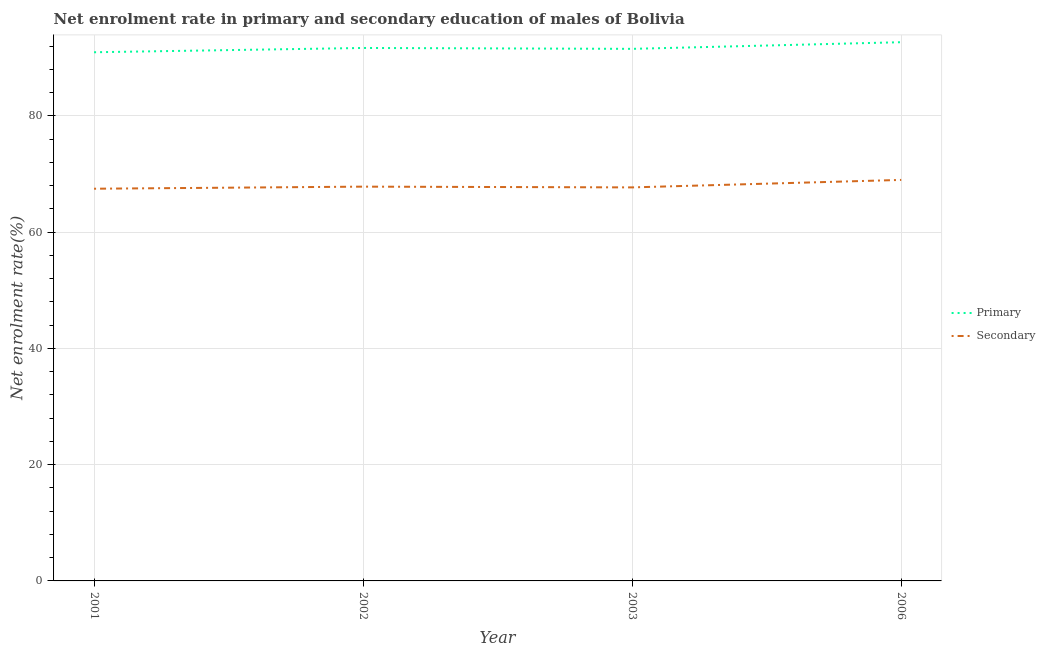Does the line corresponding to enrollment rate in secondary education intersect with the line corresponding to enrollment rate in primary education?
Give a very brief answer. No. What is the enrollment rate in secondary education in 2003?
Your answer should be very brief. 67.69. Across all years, what is the maximum enrollment rate in primary education?
Offer a very short reply. 92.66. Across all years, what is the minimum enrollment rate in secondary education?
Provide a short and direct response. 67.46. What is the total enrollment rate in primary education in the graph?
Give a very brief answer. 366.77. What is the difference between the enrollment rate in secondary education in 2001 and that in 2003?
Your answer should be very brief. -0.23. What is the difference between the enrollment rate in primary education in 2003 and the enrollment rate in secondary education in 2001?
Your response must be concise. 24.06. What is the average enrollment rate in primary education per year?
Offer a terse response. 91.69. In the year 2003, what is the difference between the enrollment rate in primary education and enrollment rate in secondary education?
Provide a succinct answer. 23.83. In how many years, is the enrollment rate in secondary education greater than 40 %?
Your response must be concise. 4. What is the ratio of the enrollment rate in primary education in 2002 to that in 2006?
Make the answer very short. 0.99. Is the difference between the enrollment rate in secondary education in 2002 and 2003 greater than the difference between the enrollment rate in primary education in 2002 and 2003?
Make the answer very short. No. What is the difference between the highest and the second highest enrollment rate in secondary education?
Provide a succinct answer. 1.16. What is the difference between the highest and the lowest enrollment rate in secondary education?
Your answer should be very brief. 1.51. In how many years, is the enrollment rate in primary education greater than the average enrollment rate in primary education taken over all years?
Provide a short and direct response. 1. Does the enrollment rate in primary education monotonically increase over the years?
Offer a very short reply. No. Is the enrollment rate in primary education strictly less than the enrollment rate in secondary education over the years?
Your answer should be very brief. No. What is the difference between two consecutive major ticks on the Y-axis?
Offer a very short reply. 20. Are the values on the major ticks of Y-axis written in scientific E-notation?
Your answer should be very brief. No. Does the graph contain grids?
Your response must be concise. Yes. Where does the legend appear in the graph?
Your response must be concise. Center right. How are the legend labels stacked?
Offer a terse response. Vertical. What is the title of the graph?
Offer a terse response. Net enrolment rate in primary and secondary education of males of Bolivia. Does "Pregnant women" appear as one of the legend labels in the graph?
Give a very brief answer. No. What is the label or title of the Y-axis?
Provide a short and direct response. Net enrolment rate(%). What is the Net enrolment rate(%) in Primary in 2001?
Your answer should be compact. 90.93. What is the Net enrolment rate(%) of Secondary in 2001?
Your answer should be very brief. 67.46. What is the Net enrolment rate(%) in Primary in 2002?
Your answer should be very brief. 91.67. What is the Net enrolment rate(%) of Secondary in 2002?
Ensure brevity in your answer.  67.82. What is the Net enrolment rate(%) of Primary in 2003?
Offer a very short reply. 91.51. What is the Net enrolment rate(%) in Secondary in 2003?
Provide a succinct answer. 67.69. What is the Net enrolment rate(%) of Primary in 2006?
Give a very brief answer. 92.66. What is the Net enrolment rate(%) in Secondary in 2006?
Your response must be concise. 68.97. Across all years, what is the maximum Net enrolment rate(%) of Primary?
Your answer should be compact. 92.66. Across all years, what is the maximum Net enrolment rate(%) of Secondary?
Provide a short and direct response. 68.97. Across all years, what is the minimum Net enrolment rate(%) in Primary?
Give a very brief answer. 90.93. Across all years, what is the minimum Net enrolment rate(%) of Secondary?
Your answer should be compact. 67.46. What is the total Net enrolment rate(%) of Primary in the graph?
Provide a succinct answer. 366.77. What is the total Net enrolment rate(%) in Secondary in the graph?
Your response must be concise. 271.93. What is the difference between the Net enrolment rate(%) of Primary in 2001 and that in 2002?
Give a very brief answer. -0.74. What is the difference between the Net enrolment rate(%) of Secondary in 2001 and that in 2002?
Your answer should be compact. -0.36. What is the difference between the Net enrolment rate(%) in Primary in 2001 and that in 2003?
Give a very brief answer. -0.58. What is the difference between the Net enrolment rate(%) of Secondary in 2001 and that in 2003?
Provide a short and direct response. -0.23. What is the difference between the Net enrolment rate(%) in Primary in 2001 and that in 2006?
Provide a short and direct response. -1.73. What is the difference between the Net enrolment rate(%) in Secondary in 2001 and that in 2006?
Make the answer very short. -1.51. What is the difference between the Net enrolment rate(%) in Primary in 2002 and that in 2003?
Offer a terse response. 0.15. What is the difference between the Net enrolment rate(%) in Secondary in 2002 and that in 2003?
Offer a very short reply. 0.13. What is the difference between the Net enrolment rate(%) of Primary in 2002 and that in 2006?
Offer a very short reply. -0.99. What is the difference between the Net enrolment rate(%) in Secondary in 2002 and that in 2006?
Your answer should be compact. -1.16. What is the difference between the Net enrolment rate(%) of Primary in 2003 and that in 2006?
Your response must be concise. -1.14. What is the difference between the Net enrolment rate(%) of Secondary in 2003 and that in 2006?
Offer a terse response. -1.29. What is the difference between the Net enrolment rate(%) of Primary in 2001 and the Net enrolment rate(%) of Secondary in 2002?
Your answer should be very brief. 23.12. What is the difference between the Net enrolment rate(%) in Primary in 2001 and the Net enrolment rate(%) in Secondary in 2003?
Your response must be concise. 23.25. What is the difference between the Net enrolment rate(%) of Primary in 2001 and the Net enrolment rate(%) of Secondary in 2006?
Make the answer very short. 21.96. What is the difference between the Net enrolment rate(%) in Primary in 2002 and the Net enrolment rate(%) in Secondary in 2003?
Offer a terse response. 23.98. What is the difference between the Net enrolment rate(%) of Primary in 2002 and the Net enrolment rate(%) of Secondary in 2006?
Your answer should be very brief. 22.69. What is the difference between the Net enrolment rate(%) of Primary in 2003 and the Net enrolment rate(%) of Secondary in 2006?
Your answer should be compact. 22.54. What is the average Net enrolment rate(%) of Primary per year?
Your answer should be very brief. 91.69. What is the average Net enrolment rate(%) of Secondary per year?
Offer a terse response. 67.98. In the year 2001, what is the difference between the Net enrolment rate(%) in Primary and Net enrolment rate(%) in Secondary?
Keep it short and to the point. 23.47. In the year 2002, what is the difference between the Net enrolment rate(%) in Primary and Net enrolment rate(%) in Secondary?
Provide a succinct answer. 23.85. In the year 2003, what is the difference between the Net enrolment rate(%) in Primary and Net enrolment rate(%) in Secondary?
Provide a succinct answer. 23.83. In the year 2006, what is the difference between the Net enrolment rate(%) in Primary and Net enrolment rate(%) in Secondary?
Make the answer very short. 23.69. What is the ratio of the Net enrolment rate(%) of Primary in 2001 to that in 2002?
Keep it short and to the point. 0.99. What is the ratio of the Net enrolment rate(%) in Secondary in 2001 to that in 2002?
Your answer should be very brief. 0.99. What is the ratio of the Net enrolment rate(%) of Primary in 2001 to that in 2003?
Your answer should be very brief. 0.99. What is the ratio of the Net enrolment rate(%) of Primary in 2001 to that in 2006?
Provide a succinct answer. 0.98. What is the ratio of the Net enrolment rate(%) in Secondary in 2002 to that in 2003?
Offer a terse response. 1. What is the ratio of the Net enrolment rate(%) in Primary in 2002 to that in 2006?
Provide a short and direct response. 0.99. What is the ratio of the Net enrolment rate(%) in Secondary in 2002 to that in 2006?
Your response must be concise. 0.98. What is the ratio of the Net enrolment rate(%) of Secondary in 2003 to that in 2006?
Your answer should be very brief. 0.98. What is the difference between the highest and the second highest Net enrolment rate(%) of Secondary?
Keep it short and to the point. 1.16. What is the difference between the highest and the lowest Net enrolment rate(%) in Primary?
Give a very brief answer. 1.73. What is the difference between the highest and the lowest Net enrolment rate(%) in Secondary?
Your answer should be compact. 1.51. 